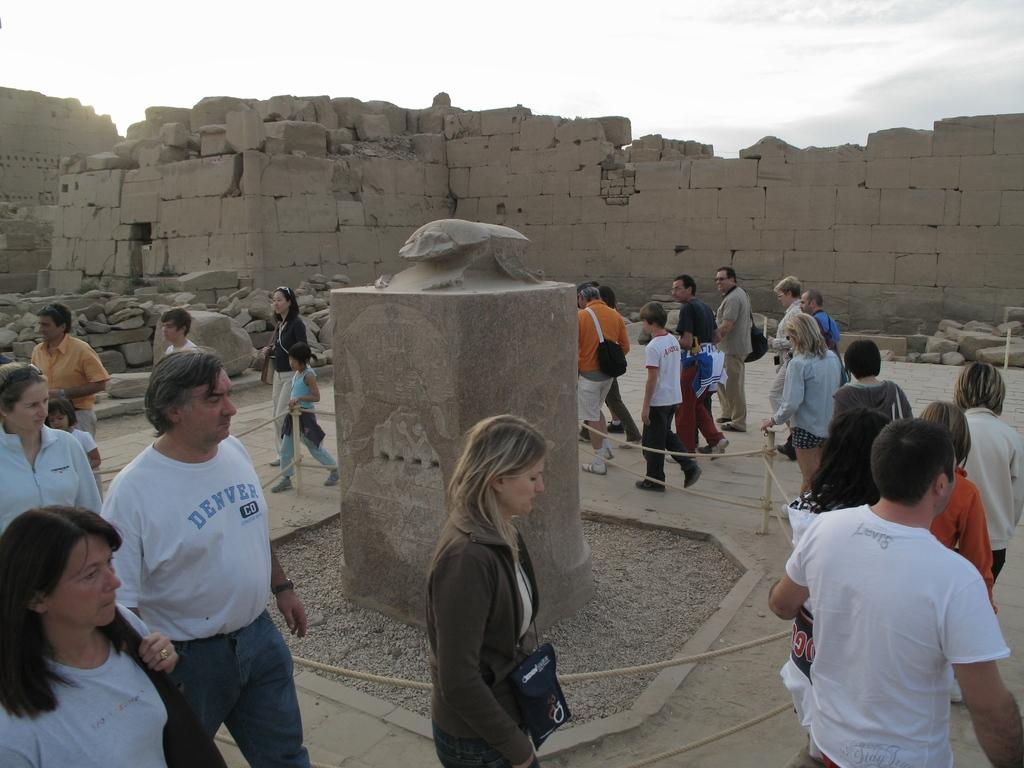How many people are in the image? There are many people in the image. What can be found on a pedestal in the image? There is a sculpture on a pedestal in the image. What are the poles with ropes used for in the image? The poles with ropes are not specified for any particular use in the image. What type of natural elements can be seen in the background of the image? There are stones and the sky with clouds visible in the background of the image. What type of mask is being worn by the people in the image? There are no masks visible on the people in the image. How does the cave in the image contribute to the overall scene? There is no cave present in the image. 